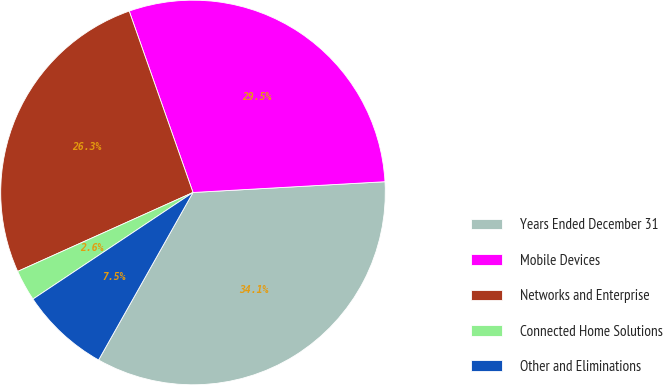Convert chart to OTSL. <chart><loc_0><loc_0><loc_500><loc_500><pie_chart><fcel>Years Ended December 31<fcel>Mobile Devices<fcel>Networks and Enterprise<fcel>Connected Home Solutions<fcel>Other and Eliminations<nl><fcel>34.06%<fcel>29.49%<fcel>26.35%<fcel>2.62%<fcel>7.48%<nl></chart> 